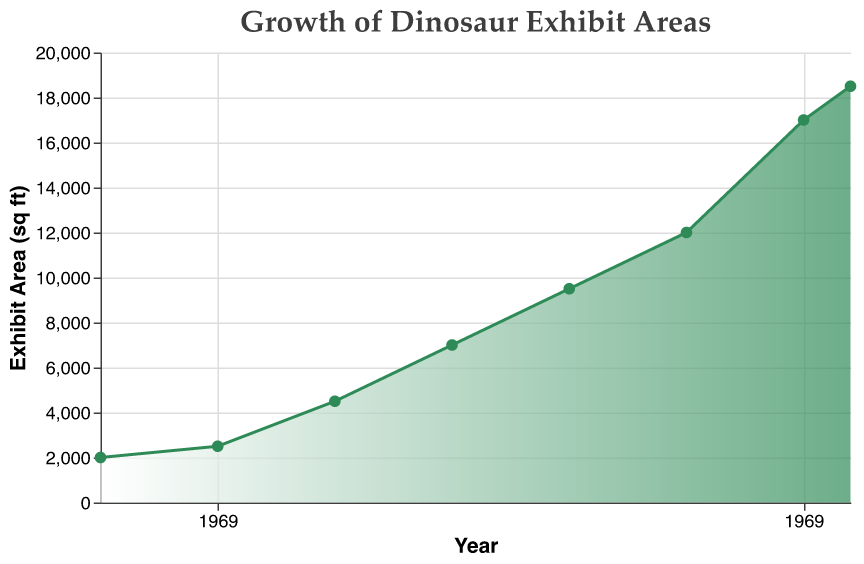What is the title of the chart? The title is usually located at the top of the chart. The title text in this case is "Growth of Dinosaur Exhibit Areas".
Answer: Growth of Dinosaur Exhibit Areas How many years of data are shown in the chart? The x-axis represents the years, and counting the number of unique data points along this axis tells us the number of years. There are data points for 1990, 1995, 2000, 2005, 2010, 2015, 2020, and 2022.
Answer: 8 What was the exhibit area in square feet in the year 2000? Locate the year 2000 on the x-axis and find the corresponding point on the area chart. The y-axis value at this point gives the exhibit area, which is 4500 square feet.
Answer: 4500 By how much did the exhibit area grow between 2000 and 2010? Find the exhibit area values for the years 2000 and 2010, which are 4500 and 9500 square feet respectively, and subtract the two values: 9500 - 4500 = 5000 square feet.
Answer: 5000 Which year experienced the largest increase in exhibit area compared to the previous data point? Evaluate the differences between consecutive data points:
1990-1995: 2500 - 2000 = 500,
1995-2000: 4500 - 2500 = 2000,
2000-2005: 7000 - 4500 = 2500,
2005-2010: 9500 - 7000 = 2500,
2010-2015: 12000 - 9500 = 2500,
2015-2020: 17000 - 12000 = 5000,
2020-2022: 18500 - 17000 = 1500.
The largest increase is from 2015 to 2020, at 5000 square feet.
Answer: 2015-2020 What is the average growth per year over the entire period? First, calculate the total growth over the period by subtracting the initial area from the final area: 18500 - 2000 = 16500. Then, divide by the time period (2022 - 1990 = 32 years). The average growth per year is 16500 / 32 ≈ 515.63 square feet per year.
Answer: 515.63 What is the range of exhibit area sizes shown in the chart? The range is the difference between the maximum and minimum values on the y-axis. The minimum is 2000 square feet (1990) and the maximum is 18500 square feet (2022). The range is 18500 - 2000 = 16500 square feet.
Answer: 16500 Is the growth in exhibit area linear over the years? By examining the shape of the area chart, observe if the increases between data points are consistent. The growth shown is not linear as the differences vary significantly between years, indicating non-linear growth.
Answer: No What trend is depicted by the area chart? The chart shows a general increasing trend in exhibit area size over time, with fluctuations in the rate of increase. The area consistently grows larger from 1990 to 2022.
Answer: Increasing trend In which period did the exhibit area more than double? Compare the exhibit areas at different points to find a doubling. From 1990 to 2020, the area grew from 2000 to 17000 square feet, which is more than an eight-fold increase, meaning it more than doubled at some point within this interval.
Answer: 1990-2020 